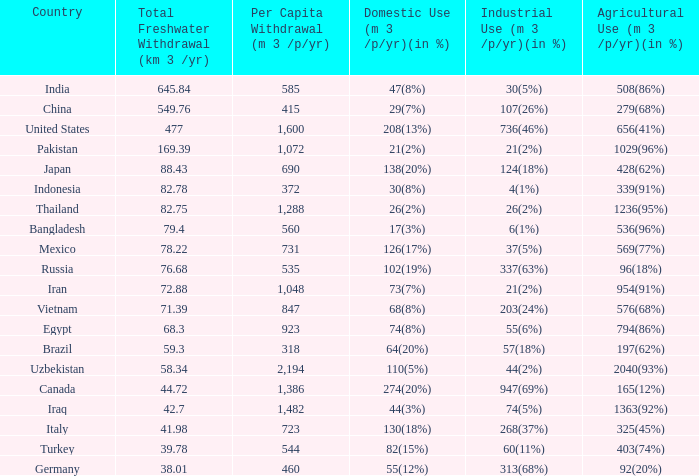What is the highest Per Capita Withdrawal (m 3 /p/yr), when Agricultural Use (m 3 /p/yr)(in %) is 1363(92%), and when Total Freshwater Withdrawal (km 3 /yr) is less than 42.7? None. 